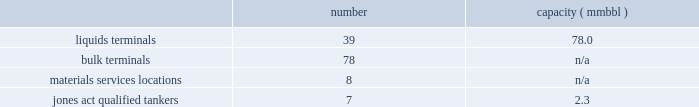In direct competition with other co2 pipelines .
We also compete with other interest owners in the mcelmo dome unit and the bravo dome unit for transportation of co2 to the denver city , texas market area .
Terminals our terminals segment includes the operations of our petroleum , chemical , ethanol and other liquids terminal facilities ( other than those included in the products pipelines segment ) and all of our coal , petroleum coke , fertilizer , steel , ores and other dry-bulk material services facilities , including all transload , engineering , conveying and other in-plant services .
Our terminals are located throughout the u.s .
And in portions of canada .
We believe the location of our facilities and our ability to provide flexibility to customers help attract new and retain existing customers at our terminals and provide us opportunities for expansion .
We often classify our terminal operations based on the handling of either liquids or dry-bulk material products .
In addition , we have jones act qualified product tankers that provide marine transportation of crude oil , condensate and refined products in the u.s .
The following summarizes our terminals segment assets , as of december 31 , 2014 : number capacity ( mmbbl ) .
Competition we are one of the largest independent operators of liquids terminals in the u.s , based on barrels of liquids terminaling capacity .
Our liquids terminals compete with other publicly or privately held independent liquids terminals , and terminals owned by oil , chemical and pipeline companies .
Our bulk terminals compete with numerous independent terminal operators , terminals owned by producers and distributors of bulk commodities , stevedoring companies and other industrial companies opting not to outsource terminal services .
In some locations , competitors are smaller , independent operators with lower cost structures .
Our rail transloading ( material services ) operations compete with a variety of single- or multi-site transload , warehouse and terminal operators across the u.s .
Our jones act qualified product tankers compete with other jones act qualified vessel fleets .
Table of contents .
What is the average capacity per liquids terminal in mmbbl? 
Computations: (78.0 / 39)
Answer: 2.0. 